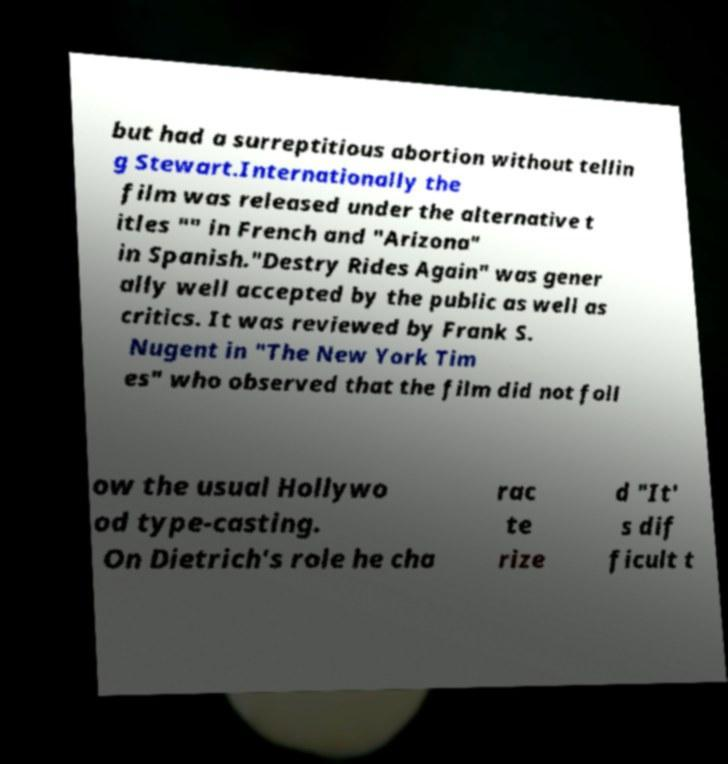Please identify and transcribe the text found in this image. but had a surreptitious abortion without tellin g Stewart.Internationally the film was released under the alternative t itles "" in French and "Arizona" in Spanish."Destry Rides Again" was gener ally well accepted by the public as well as critics. It was reviewed by Frank S. Nugent in "The New York Tim es" who observed that the film did not foll ow the usual Hollywo od type-casting. On Dietrich's role he cha rac te rize d "It' s dif ficult t 